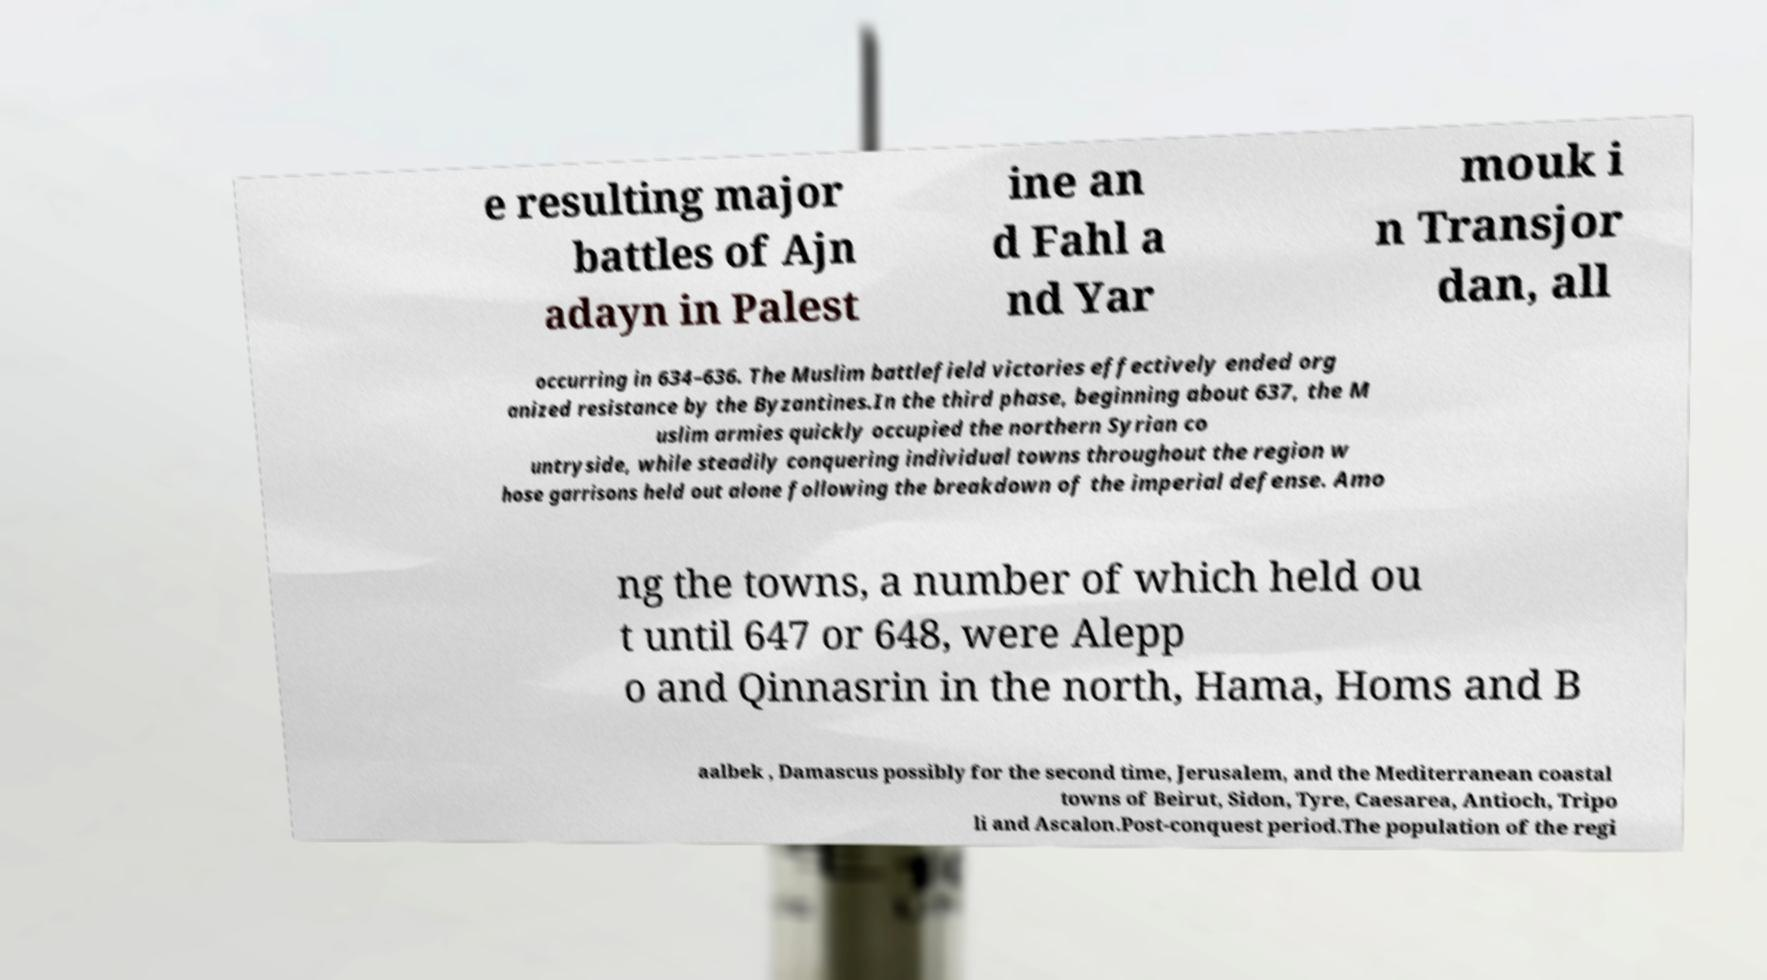Could you extract and type out the text from this image? e resulting major battles of Ajn adayn in Palest ine an d Fahl a nd Yar mouk i n Transjor dan, all occurring in 634–636. The Muslim battlefield victories effectively ended org anized resistance by the Byzantines.In the third phase, beginning about 637, the M uslim armies quickly occupied the northern Syrian co untryside, while steadily conquering individual towns throughout the region w hose garrisons held out alone following the breakdown of the imperial defense. Amo ng the towns, a number of which held ou t until 647 or 648, were Alepp o and Qinnasrin in the north, Hama, Homs and B aalbek , Damascus possibly for the second time, Jerusalem, and the Mediterranean coastal towns of Beirut, Sidon, Tyre, Caesarea, Antioch, Tripo li and Ascalon.Post-conquest period.The population of the regi 